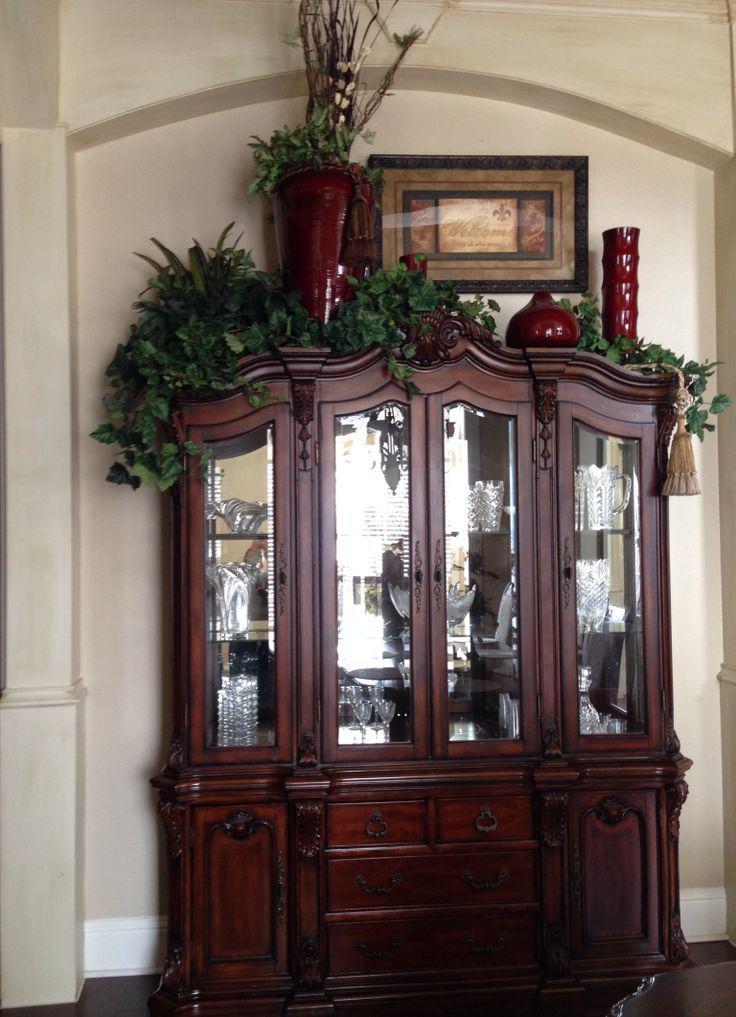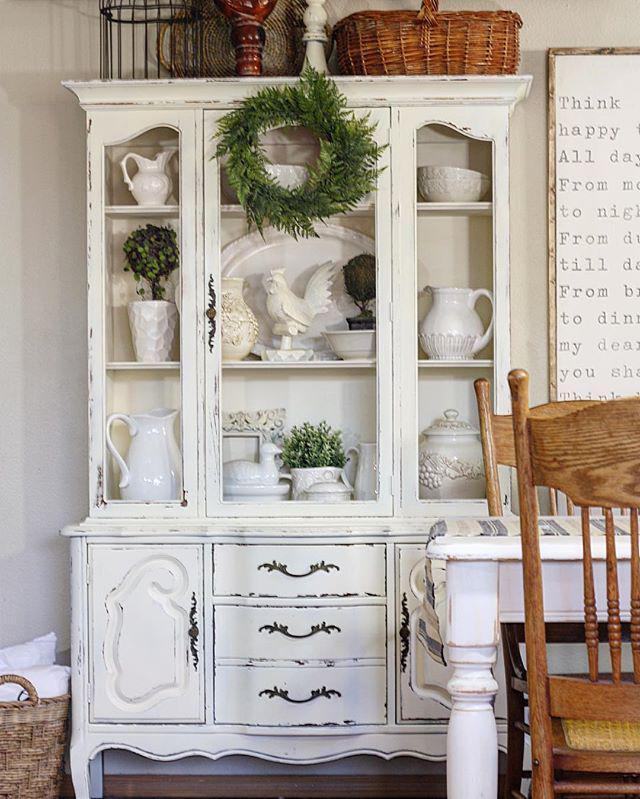The first image is the image on the left, the second image is the image on the right. Evaluate the accuracy of this statement regarding the images: "A wooden hutch with three glass doors in its upper section has a center section of drawers between two solid doors in the bottom section.". Is it true? Answer yes or no. Yes. The first image is the image on the left, the second image is the image on the right. Considering the images on both sides, is "The cabinet on the left is rich brown wood, and the cabinet on the right is white, with scrollwork and legs on the base." valid? Answer yes or no. Yes. 